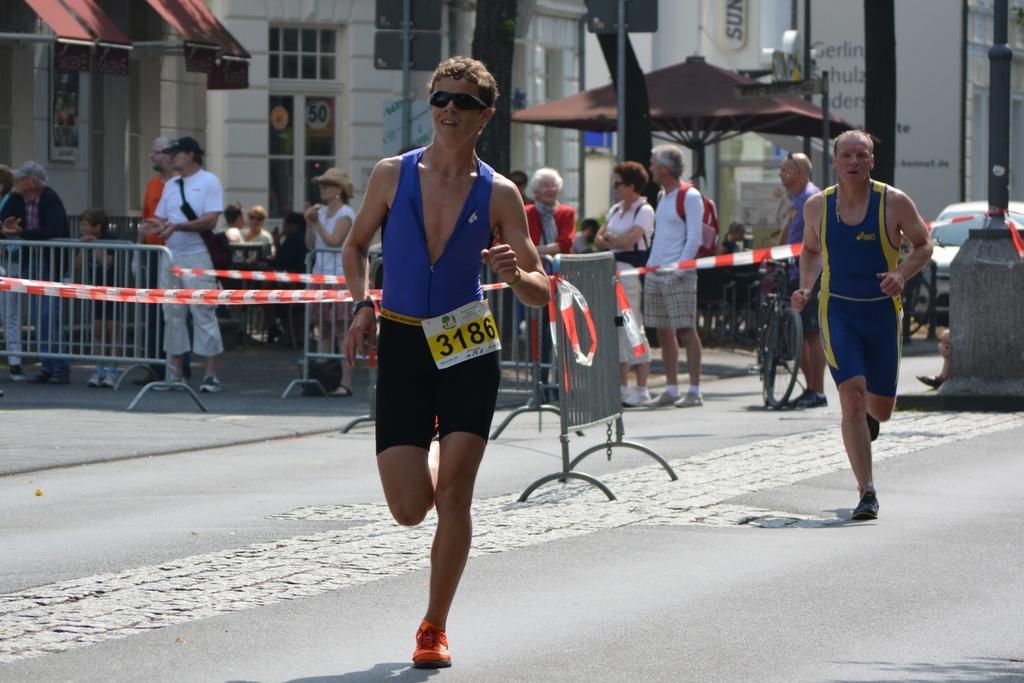Please provide a concise description of this image. In this picture there are two persons running on the road and there are few persons,trees and a vehicle in the background. 